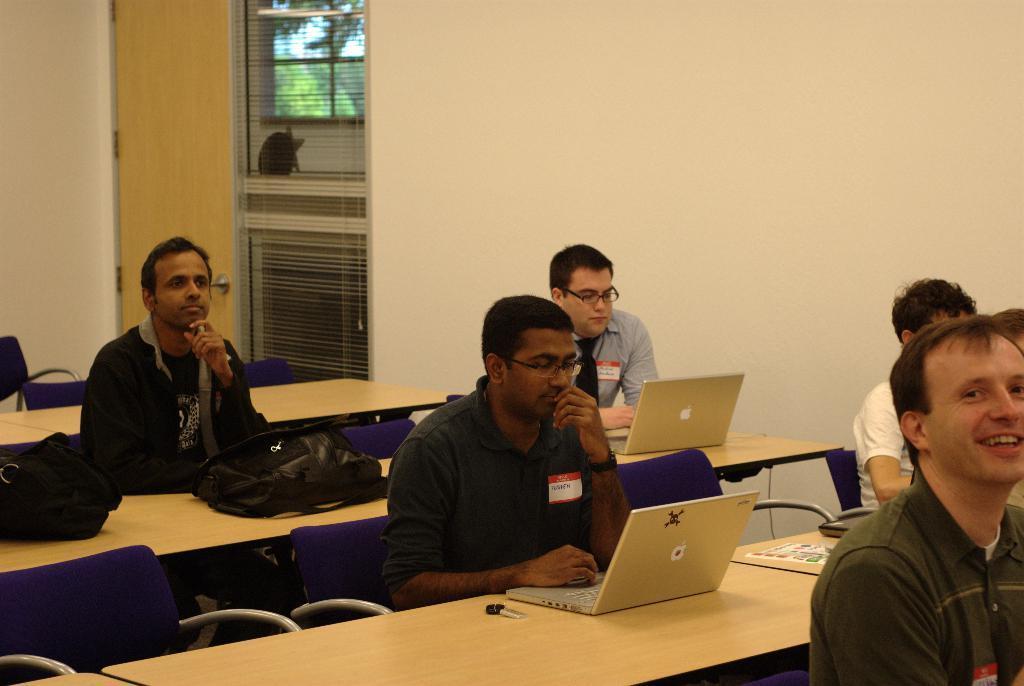Describe this image in one or two sentences. The picture is taken inside a room. There are few men sitting in the chairs at table. There are laptops, backpacks and file on the table. The man at the right corner is wearing a black jacket. The man beside him is wearing a shirt, tie and spectacles and is working on a laptop. The man at the right corner is smiling. In the background there is wall and window blinds. Out side of the room there are trees which can be seen from the window. 